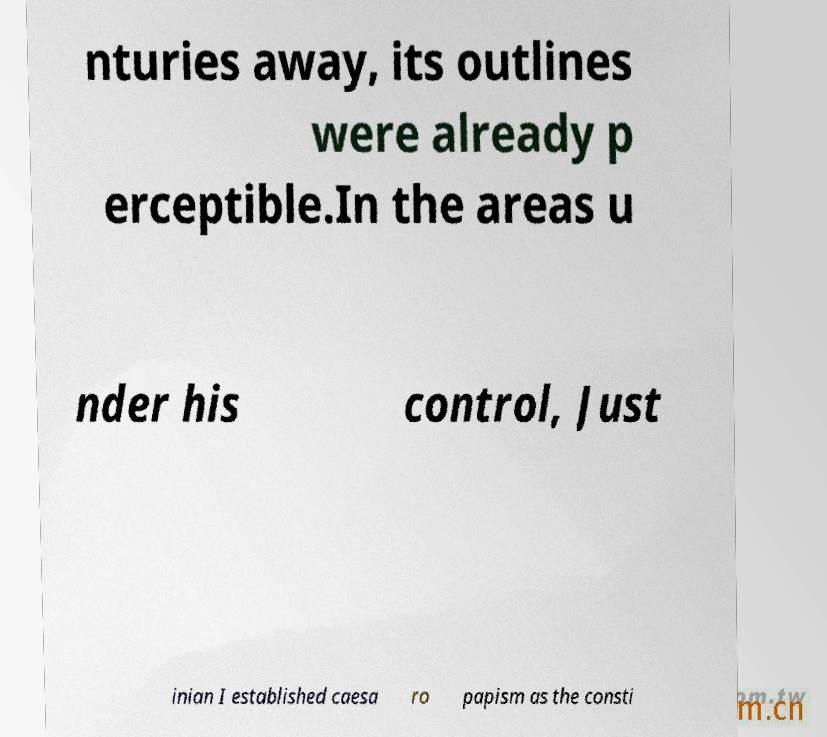Can you accurately transcribe the text from the provided image for me? nturies away, its outlines were already p erceptible.In the areas u nder his control, Just inian I established caesa ro papism as the consti 